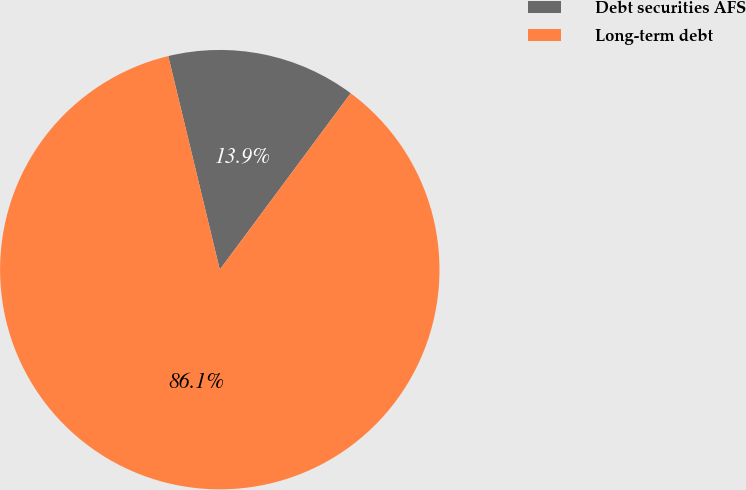Convert chart. <chart><loc_0><loc_0><loc_500><loc_500><pie_chart><fcel>Debt securities AFS<fcel>Long-term debt<nl><fcel>13.93%<fcel>86.07%<nl></chart> 